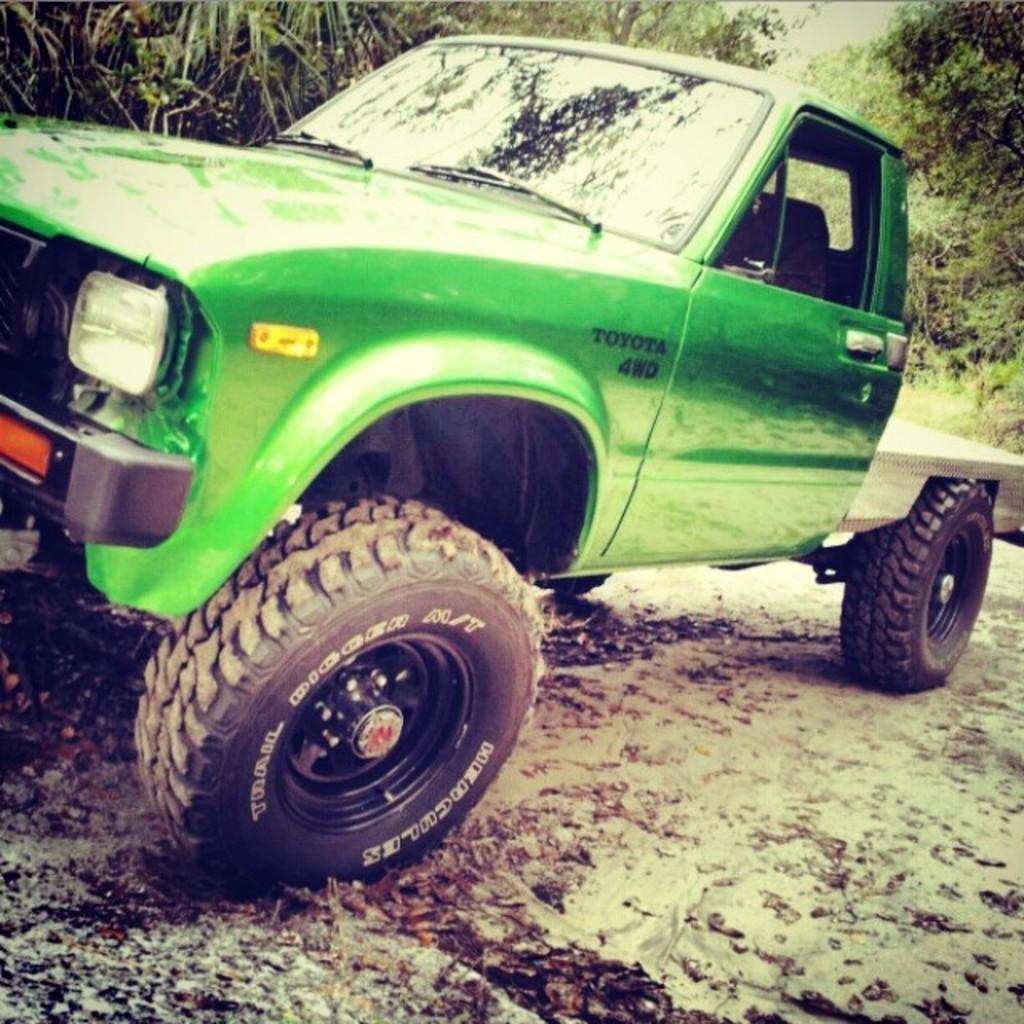What type of vehicle is in the image? There is a green truck in the image. What is the position of the truck in the image? The truck is on the ground. What can be seen in the background of the image? There are trees in the background of the image. Reasoning: Let'g: Let's think step by step in order to produce the conversation. We start by identifying the main subject in the image, which is the green truck. Then, we describe the position of the truck, which is on the ground. Finally, we mention the background of the image, which includes trees. Each question is designed to elicit a specific detail about the image that is known from the provided facts. Absurd Question/Answer: What type of writing can be seen on the truck in the image? There is no writing visible on the truck in the image. How many feet are visible on the truck in the image? There are no feet visible on the truck in the image. What type of destruction can be seen happening to the truck in the image? There is no destruction happening to the truck in the image; it appears to be in a stationary position on the ground. 